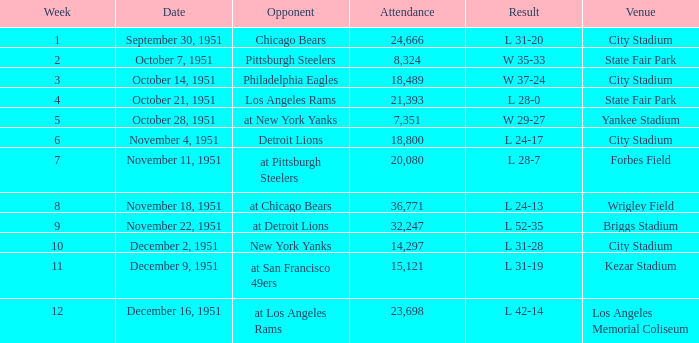What date had a week beyond 4 at city stadium and an attendance of more than 14,297? November 4, 1951. 